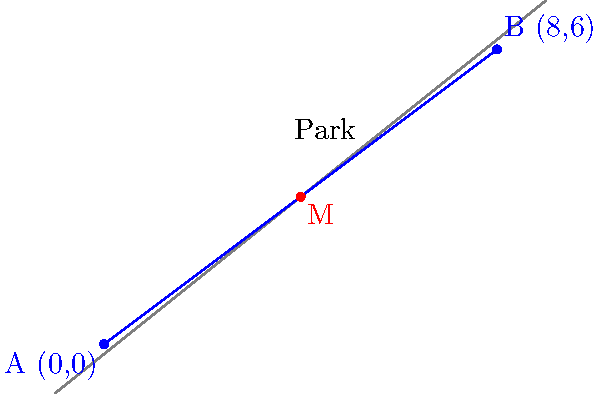Spot and Buddy are playing fetch in the park. Spot is at point A (0,0), and Buddy is at point B (8,6). You want to throw the ball so it lands exactly between them. What are the coordinates of the midpoint M where you should aim to throw the ball? Let's find the midpoint step-by-step:

1. The midpoint formula is: $M = (\frac{x_1 + x_2}{2}, \frac{y_1 + y_2}{2})$

2. We know:
   Spot's position (A): $(x_1, y_1) = (0, 0)$
   Buddy's position (B): $(x_2, y_2) = (8, 6)$

3. Let's calculate the x-coordinate of the midpoint:
   $x = \frac{x_1 + x_2}{2} = \frac{0 + 8}{2} = \frac{8}{2} = 4$

4. Now, let's calculate the y-coordinate of the midpoint:
   $y = \frac{y_1 + y_2}{2} = \frac{0 + 6}{2} = \frac{6}{2} = 3$

5. Therefore, the midpoint M has coordinates (4, 3).

This is where you should aim to throw the ball so it lands exactly between Spot and Buddy!
Answer: (4, 3) 